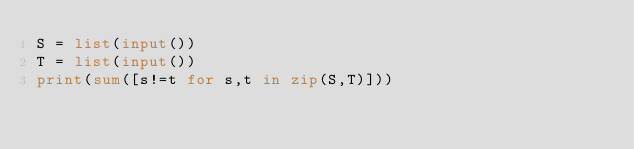Convert code to text. <code><loc_0><loc_0><loc_500><loc_500><_Python_>S = list(input())
T = list(input())
print(sum([s!=t for s,t in zip(S,T)]))</code> 